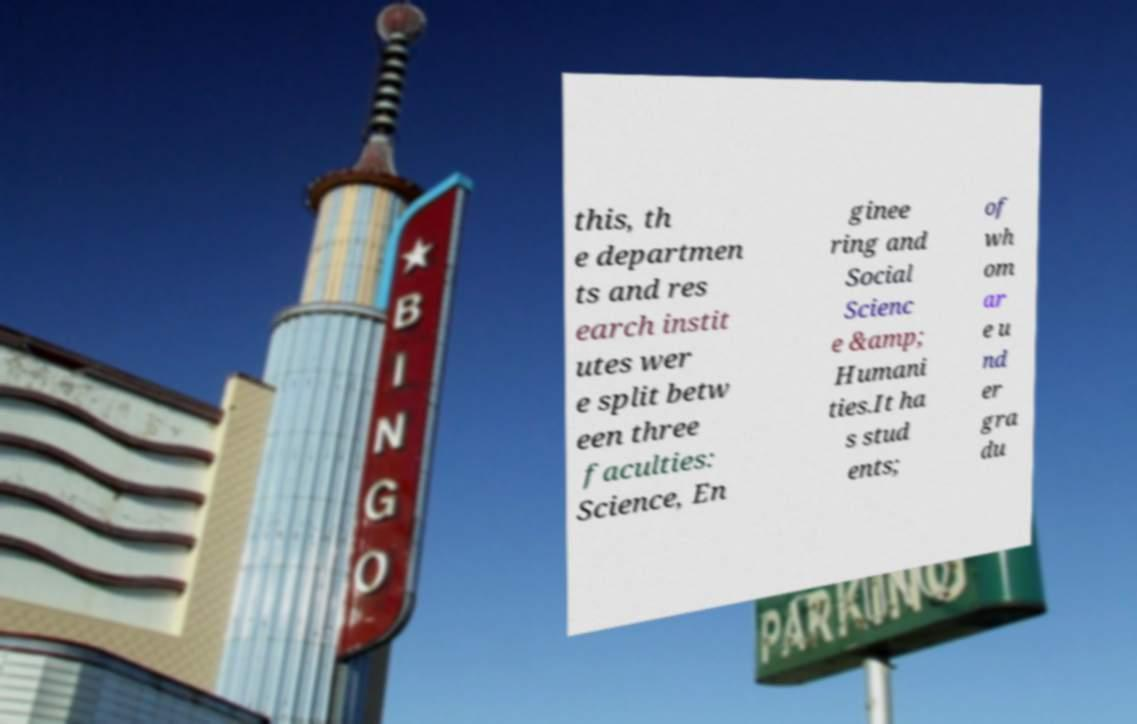Can you read and provide the text displayed in the image?This photo seems to have some interesting text. Can you extract and type it out for me? this, th e departmen ts and res earch instit utes wer e split betw een three faculties: Science, En ginee ring and Social Scienc e &amp; Humani ties.It ha s stud ents; of wh om ar e u nd er gra du 